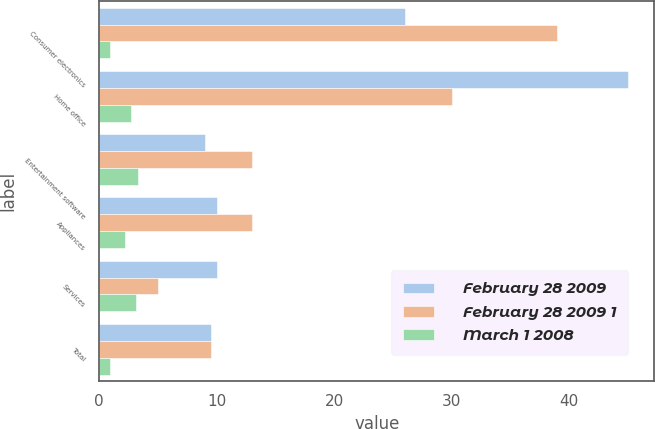Convert chart to OTSL. <chart><loc_0><loc_0><loc_500><loc_500><stacked_bar_chart><ecel><fcel>Consumer electronics<fcel>Home office<fcel>Entertainment software<fcel>Appliances<fcel>Services<fcel>Total<nl><fcel>February 28 2009<fcel>26<fcel>45<fcel>9<fcel>10<fcel>10<fcel>9.5<nl><fcel>February 28 2009 1<fcel>39<fcel>30<fcel>13<fcel>13<fcel>5<fcel>9.5<nl><fcel>March 1 2008<fcel>0.9<fcel>2.7<fcel>3.3<fcel>2.2<fcel>3.1<fcel>0.9<nl></chart> 